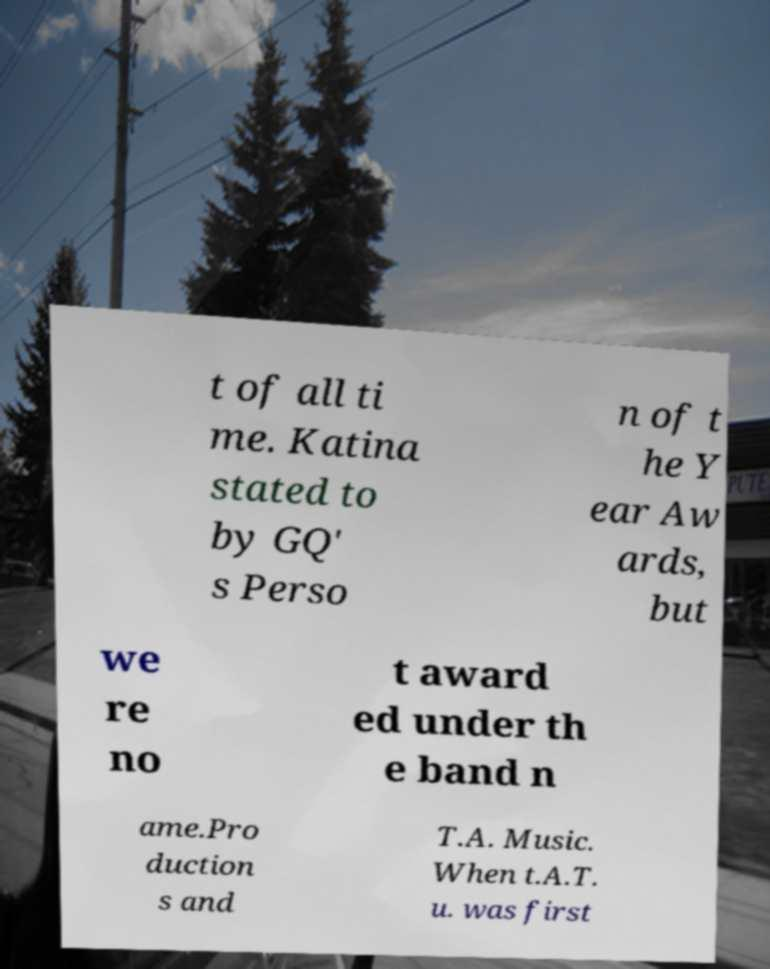Can you accurately transcribe the text from the provided image for me? t of all ti me. Katina stated to by GQ' s Perso n of t he Y ear Aw ards, but we re no t award ed under th e band n ame.Pro duction s and T.A. Music. When t.A.T. u. was first 